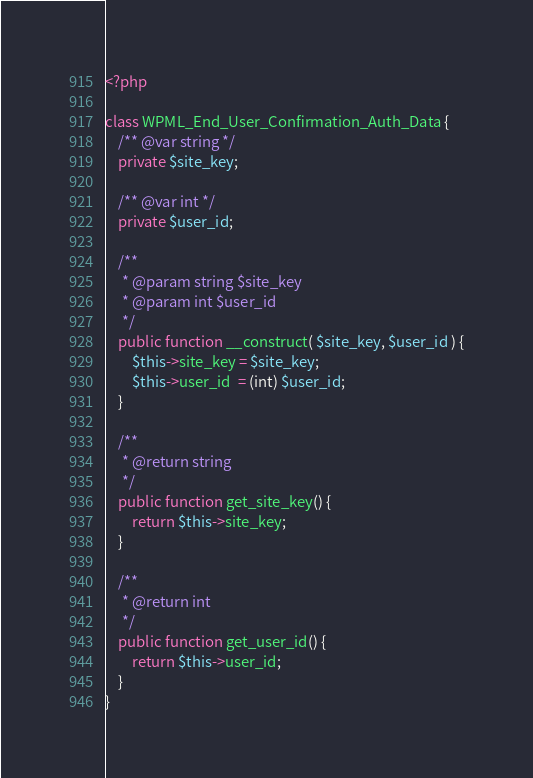Convert code to text. <code><loc_0><loc_0><loc_500><loc_500><_PHP_><?php

class WPML_End_User_Confirmation_Auth_Data {
	/** @var string */
	private $site_key;

	/** @var int */
	private $user_id;

	/**
	 * @param string $site_key
	 * @param int $user_id
	 */
	public function __construct( $site_key, $user_id ) {
		$this->site_key = $site_key;
		$this->user_id  = (int) $user_id;
	}

	/**
	 * @return string
	 */
	public function get_site_key() {
		return $this->site_key;
	}

	/**
	 * @return int
	 */
	public function get_user_id() {
		return $this->user_id;
	}
}</code> 